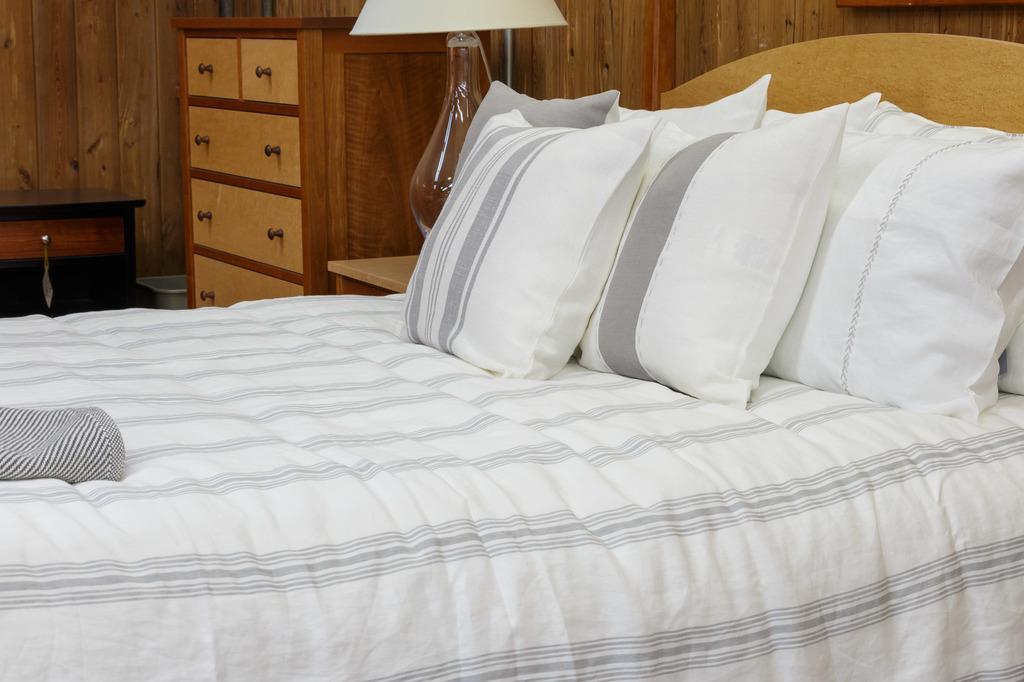Could you give a brief overview of what you see in this image? there is a bed on which there are many pillows. the bed-sheet and pillow covers are white in color. behind that there is a lamp and a cupboard. 